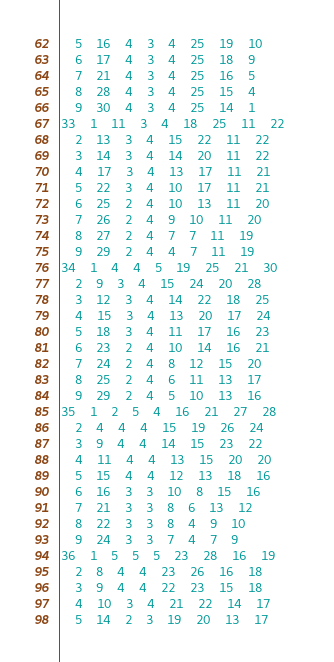<code> <loc_0><loc_0><loc_500><loc_500><_ObjectiveC_>	5	16	4	3	4	25	19	10	
	6	17	4	3	4	25	18	9	
	7	21	4	3	4	25	16	5	
	8	28	4	3	4	25	15	4	
	9	30	4	3	4	25	14	1	
33	1	11	3	4	18	25	11	22	
	2	13	3	4	15	22	11	22	
	3	14	3	4	14	20	11	22	
	4	17	3	4	13	17	11	21	
	5	22	3	4	10	17	11	21	
	6	25	2	4	10	13	11	20	
	7	26	2	4	9	10	11	20	
	8	27	2	4	7	7	11	19	
	9	29	2	4	4	7	11	19	
34	1	4	4	5	19	25	21	30	
	2	9	3	4	15	24	20	28	
	3	12	3	4	14	22	18	25	
	4	15	3	4	13	20	17	24	
	5	18	3	4	11	17	16	23	
	6	23	2	4	10	14	16	21	
	7	24	2	4	8	12	15	20	
	8	25	2	4	6	11	13	17	
	9	29	2	4	5	10	13	16	
35	1	2	5	4	16	21	27	28	
	2	4	4	4	15	19	26	24	
	3	9	4	4	14	15	23	22	
	4	11	4	4	13	15	20	20	
	5	15	4	4	12	13	18	16	
	6	16	3	3	10	8	15	16	
	7	21	3	3	8	6	13	12	
	8	22	3	3	8	4	9	10	
	9	24	3	3	7	4	7	9	
36	1	5	5	5	23	28	16	19	
	2	8	4	4	23	26	16	18	
	3	9	4	4	22	23	15	18	
	4	10	3	4	21	22	14	17	
	5	14	2	3	19	20	13	17	</code> 